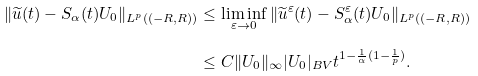Convert formula to latex. <formula><loc_0><loc_0><loc_500><loc_500>\| \widetilde { u } ( t ) - S _ { \alpha } ( t ) U _ { 0 } \| _ { L ^ { p } ( ( - R , R ) ) } & \leq \liminf _ { \varepsilon \rightarrow 0 } \| \widetilde { u } ^ { \varepsilon } ( t ) - S _ { \alpha } ^ { \varepsilon } ( t ) U _ { 0 } \| _ { L ^ { p } ( ( - R , R ) ) } \\ & \leq C \| U _ { 0 } \| _ { \infty } | U _ { 0 } | _ { B V } t ^ { 1 - \frac { 1 } { \alpha } ( 1 - \frac { 1 } { p } ) } .</formula> 